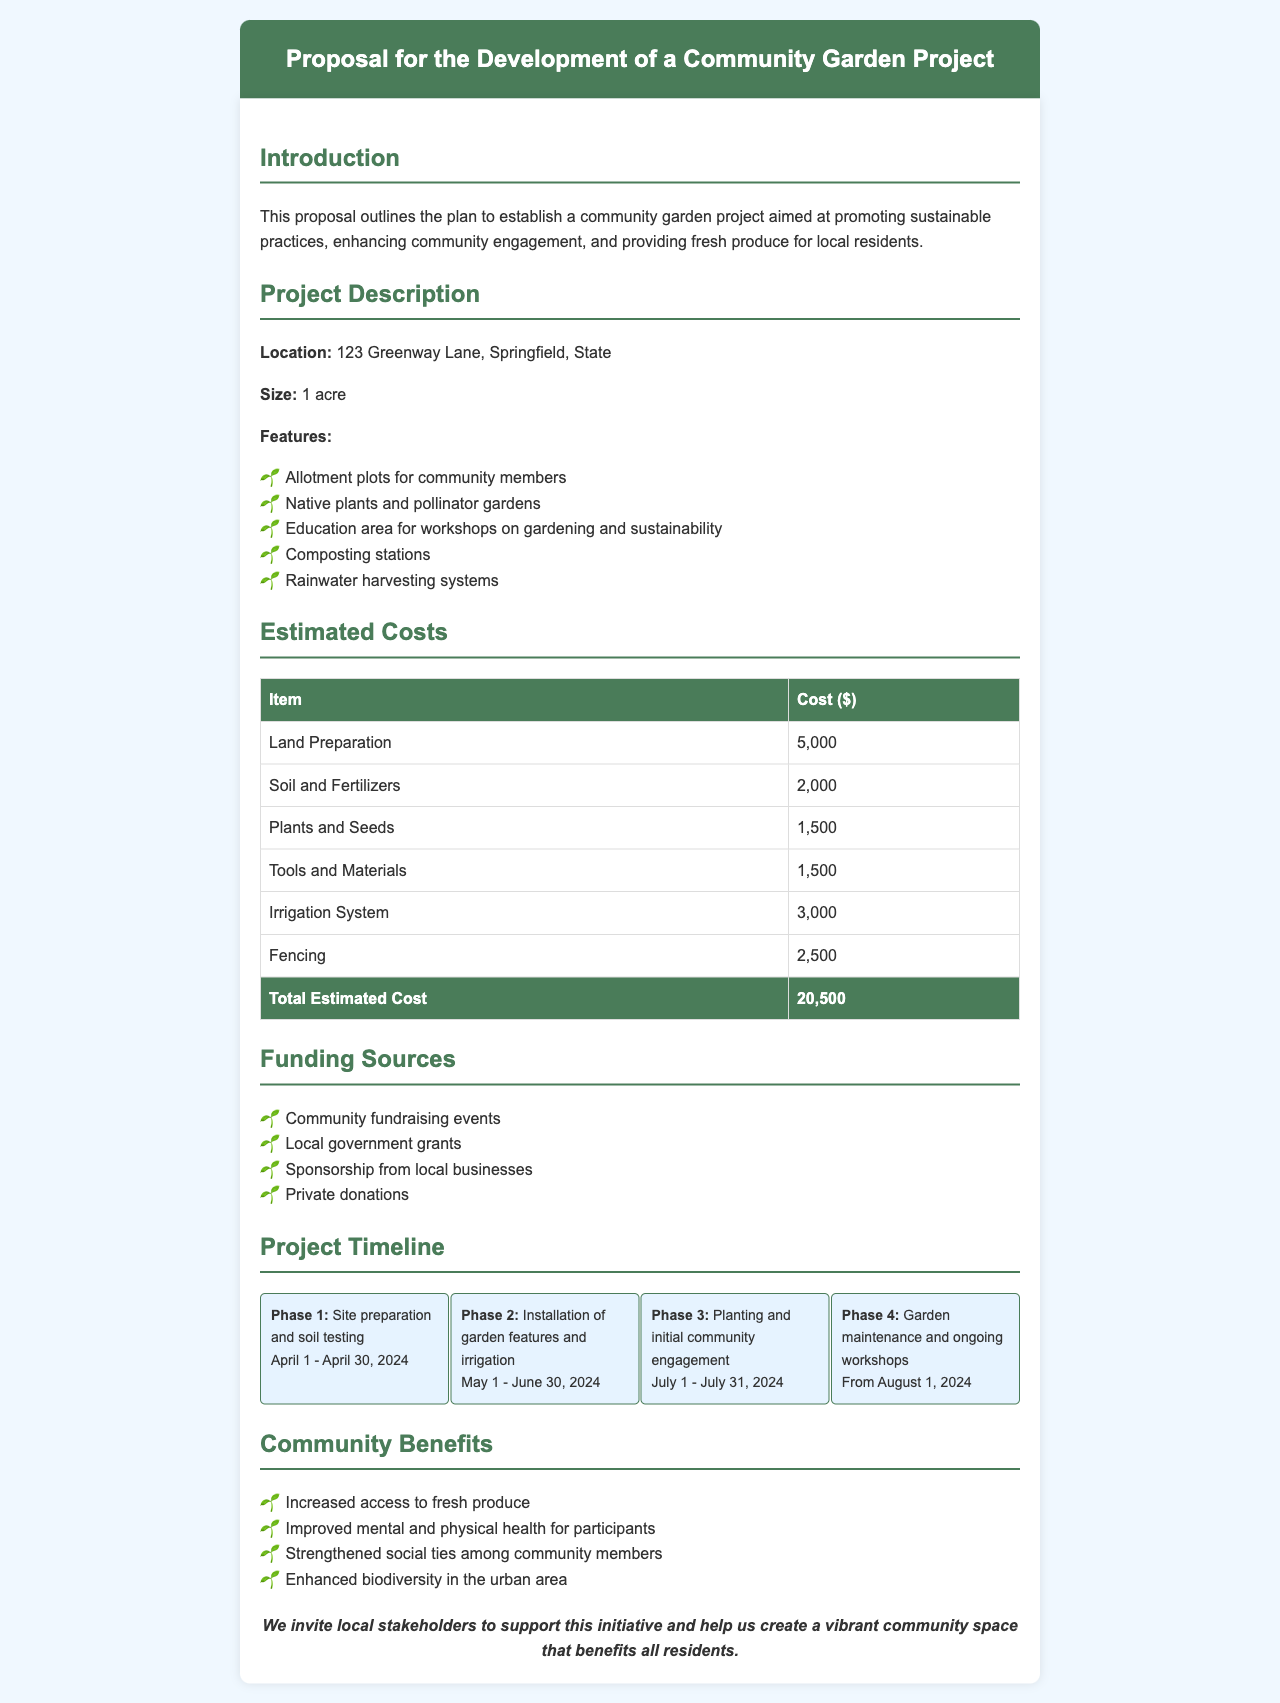What is the location of the community garden? The location of the community garden is specified in the document as 123 Greenway Lane, Springfield, State.
Answer: 123 Greenway Lane, Springfield, State What is the size of the garden? The document states that the garden will cover an area of 1 acre.
Answer: 1 acre What is the total estimated cost for the project? The total estimated cost is clearly listed in the document as $20,500.
Answer: $20,500 When does the project timeline for site preparation start and end? The timeline for site preparation begins on April 1 and ends on April 30, 2024, as indicated in the document.
Answer: April 1 - April 30, 2024 Which feature involves community education? The document lists "Education area for workshops on gardening and sustainability" as a feature of the garden.
Answer: Education area for workshops on gardening and sustainability How many phases are outlined in the project timeline? The document describes four phases in the project timeline.
Answer: Four phases What is one community benefit mentioned in the proposal? The proposal mentions "Increased access to fresh produce" as a benefit of the community garden.
Answer: Increased access to fresh produce What type of funding sources are listed? The document lists sources such as community fundraising events, local government grants, and private donations as funding sources.
Answer: Community fundraising events, local government grants, sponsorship from local businesses, private donations What is the duration of the initial community engagement phase? The initial community engagement phase is scheduled to take place from July 1 to July 31, 2024, according to the timeline in the document.
Answer: July 1 - July 31, 2024 